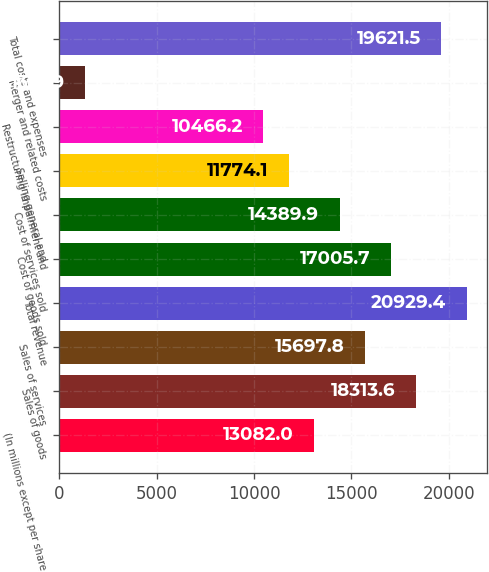Convert chart to OTSL. <chart><loc_0><loc_0><loc_500><loc_500><bar_chart><fcel>(In millions except per share<fcel>Sales of goods<fcel>Sales of services<fcel>Total revenue<fcel>Cost of goods sold<fcel>Cost of services sold<fcel>Selling general and<fcel>Restructuring impairment and<fcel>Merger and related costs<fcel>Total costs and expenses<nl><fcel>13082<fcel>18313.6<fcel>15697.8<fcel>20929.4<fcel>17005.7<fcel>14389.9<fcel>11774.1<fcel>10466.2<fcel>1310.9<fcel>19621.5<nl></chart> 